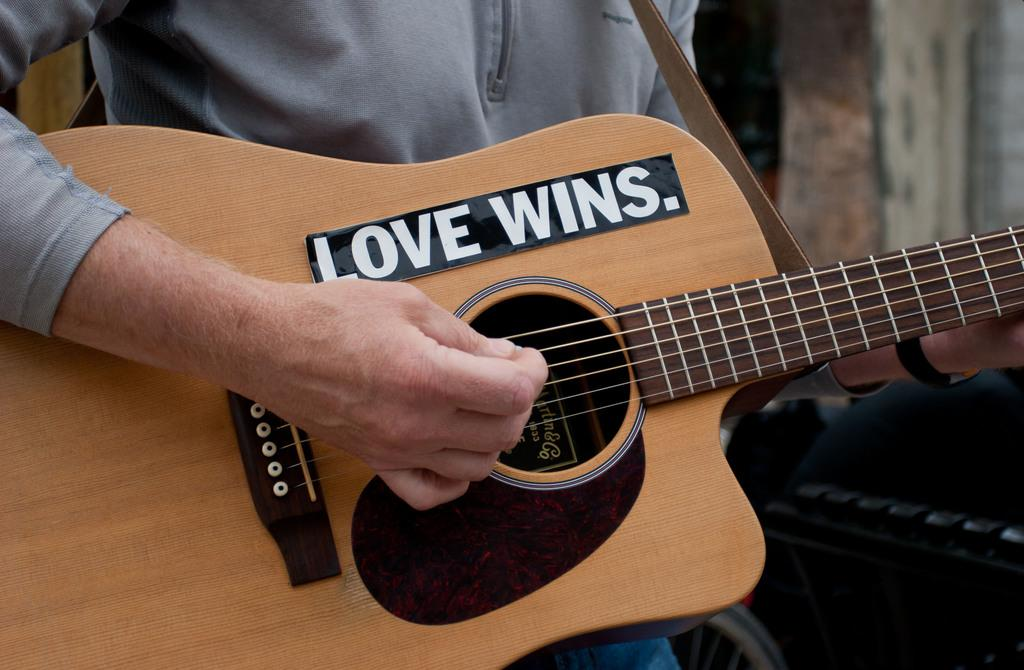What is the main subject of the image? There is a person in the image. What is the person doing in the image? The person is playing the guitar. What type of pie is being served on the table in the image? There is no table or pie present in the image; it only features a person playing the guitar. 